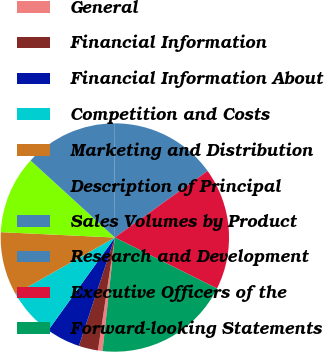<chart> <loc_0><loc_0><loc_500><loc_500><pie_chart><fcel>General<fcel>Financial Information<fcel>Financial Information About<fcel>Competition and Costs<fcel>Marketing and Distribution<fcel>Description of Principal<fcel>Sales Volumes by Product<fcel>Research and Development<fcel>Executive Officers of the<fcel>Forward-looking Statements<nl><fcel>0.65%<fcel>2.73%<fcel>4.81%<fcel>6.88%<fcel>8.96%<fcel>11.04%<fcel>13.12%<fcel>15.19%<fcel>17.27%<fcel>19.35%<nl></chart> 